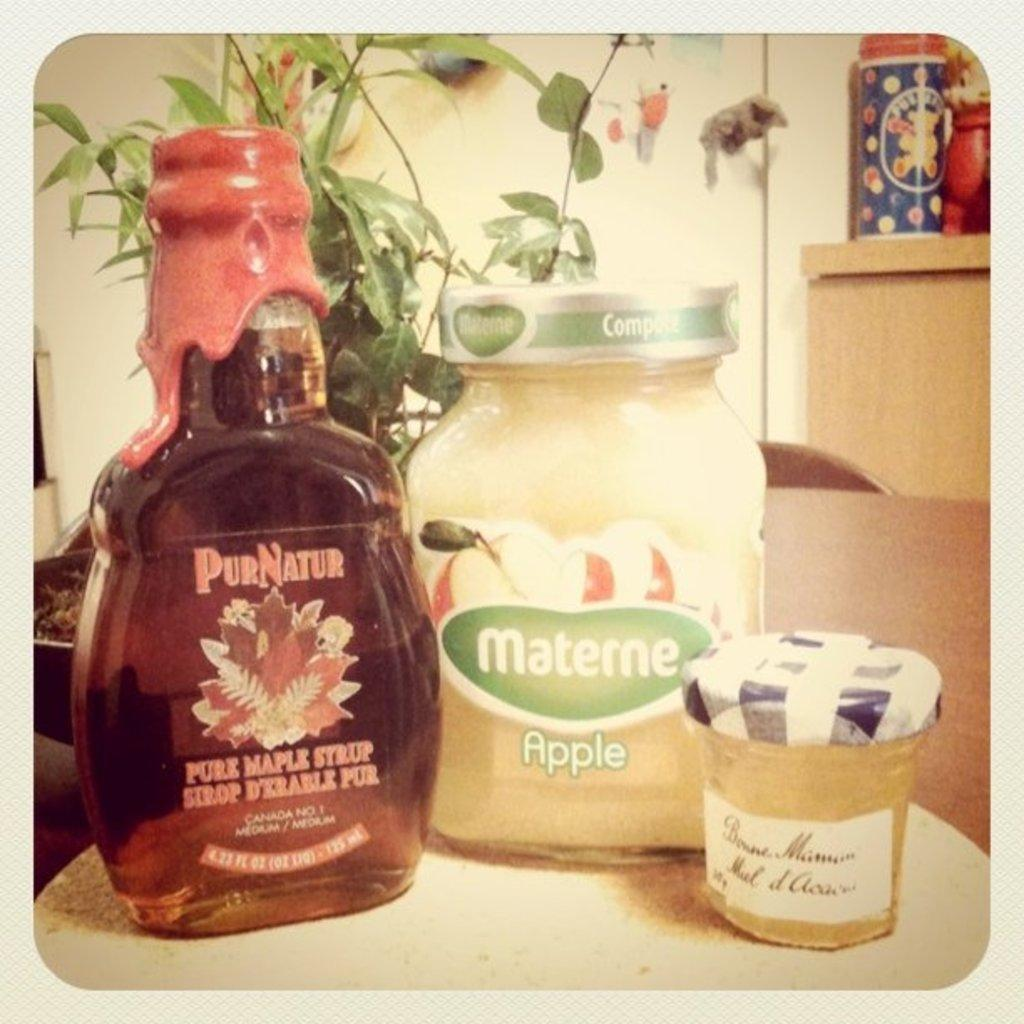<image>
Relay a brief, clear account of the picture shown. Bottle of Maple Syrup with white lettering of 4.23 fl oz. 